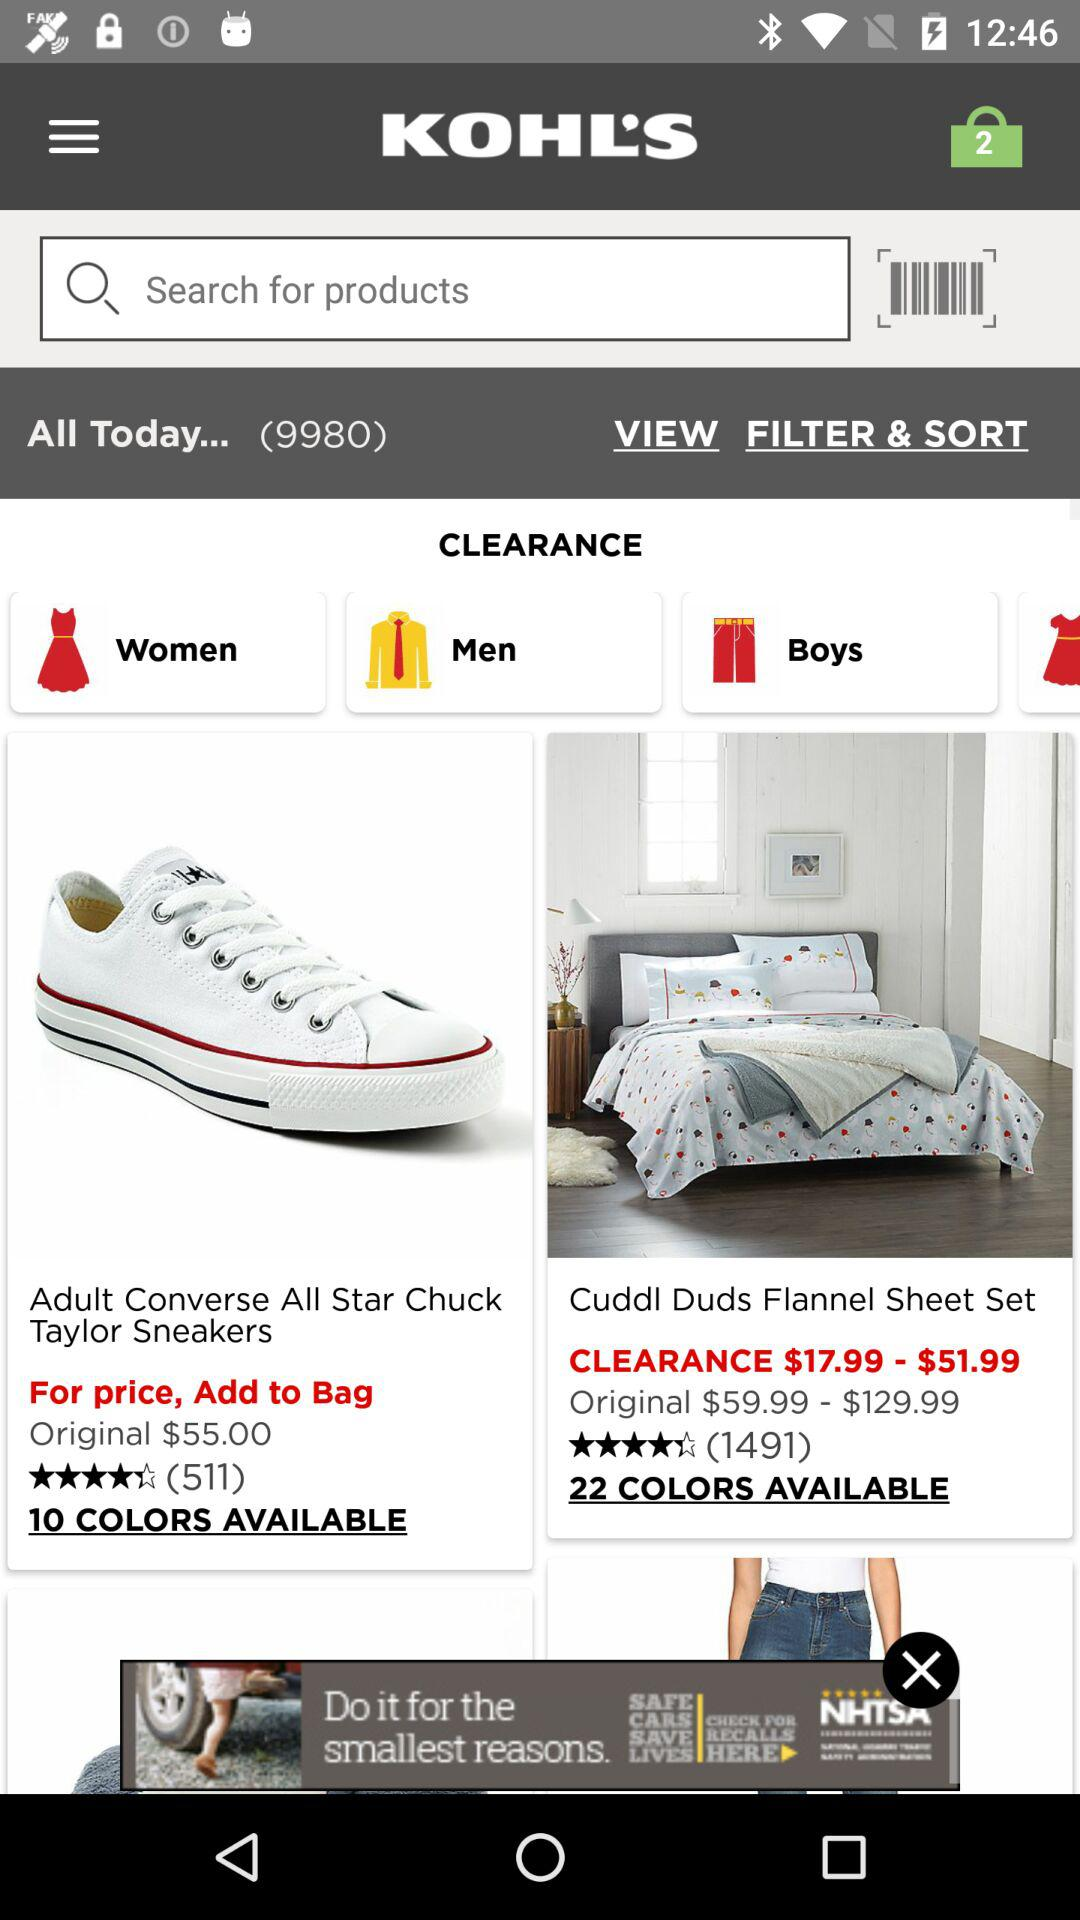What is the original price range for the sheet set? The original price range for the sheet set is from $59.99 to $129.99. 